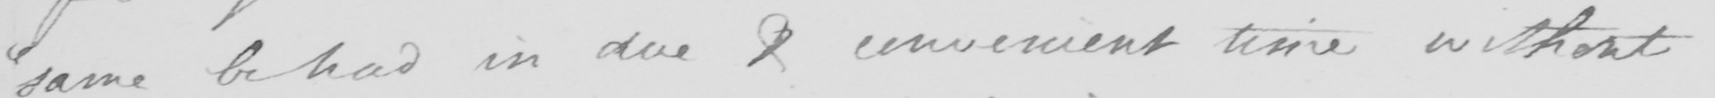Please transcribe the handwritten text in this image. " same be had in due & convenient time without 